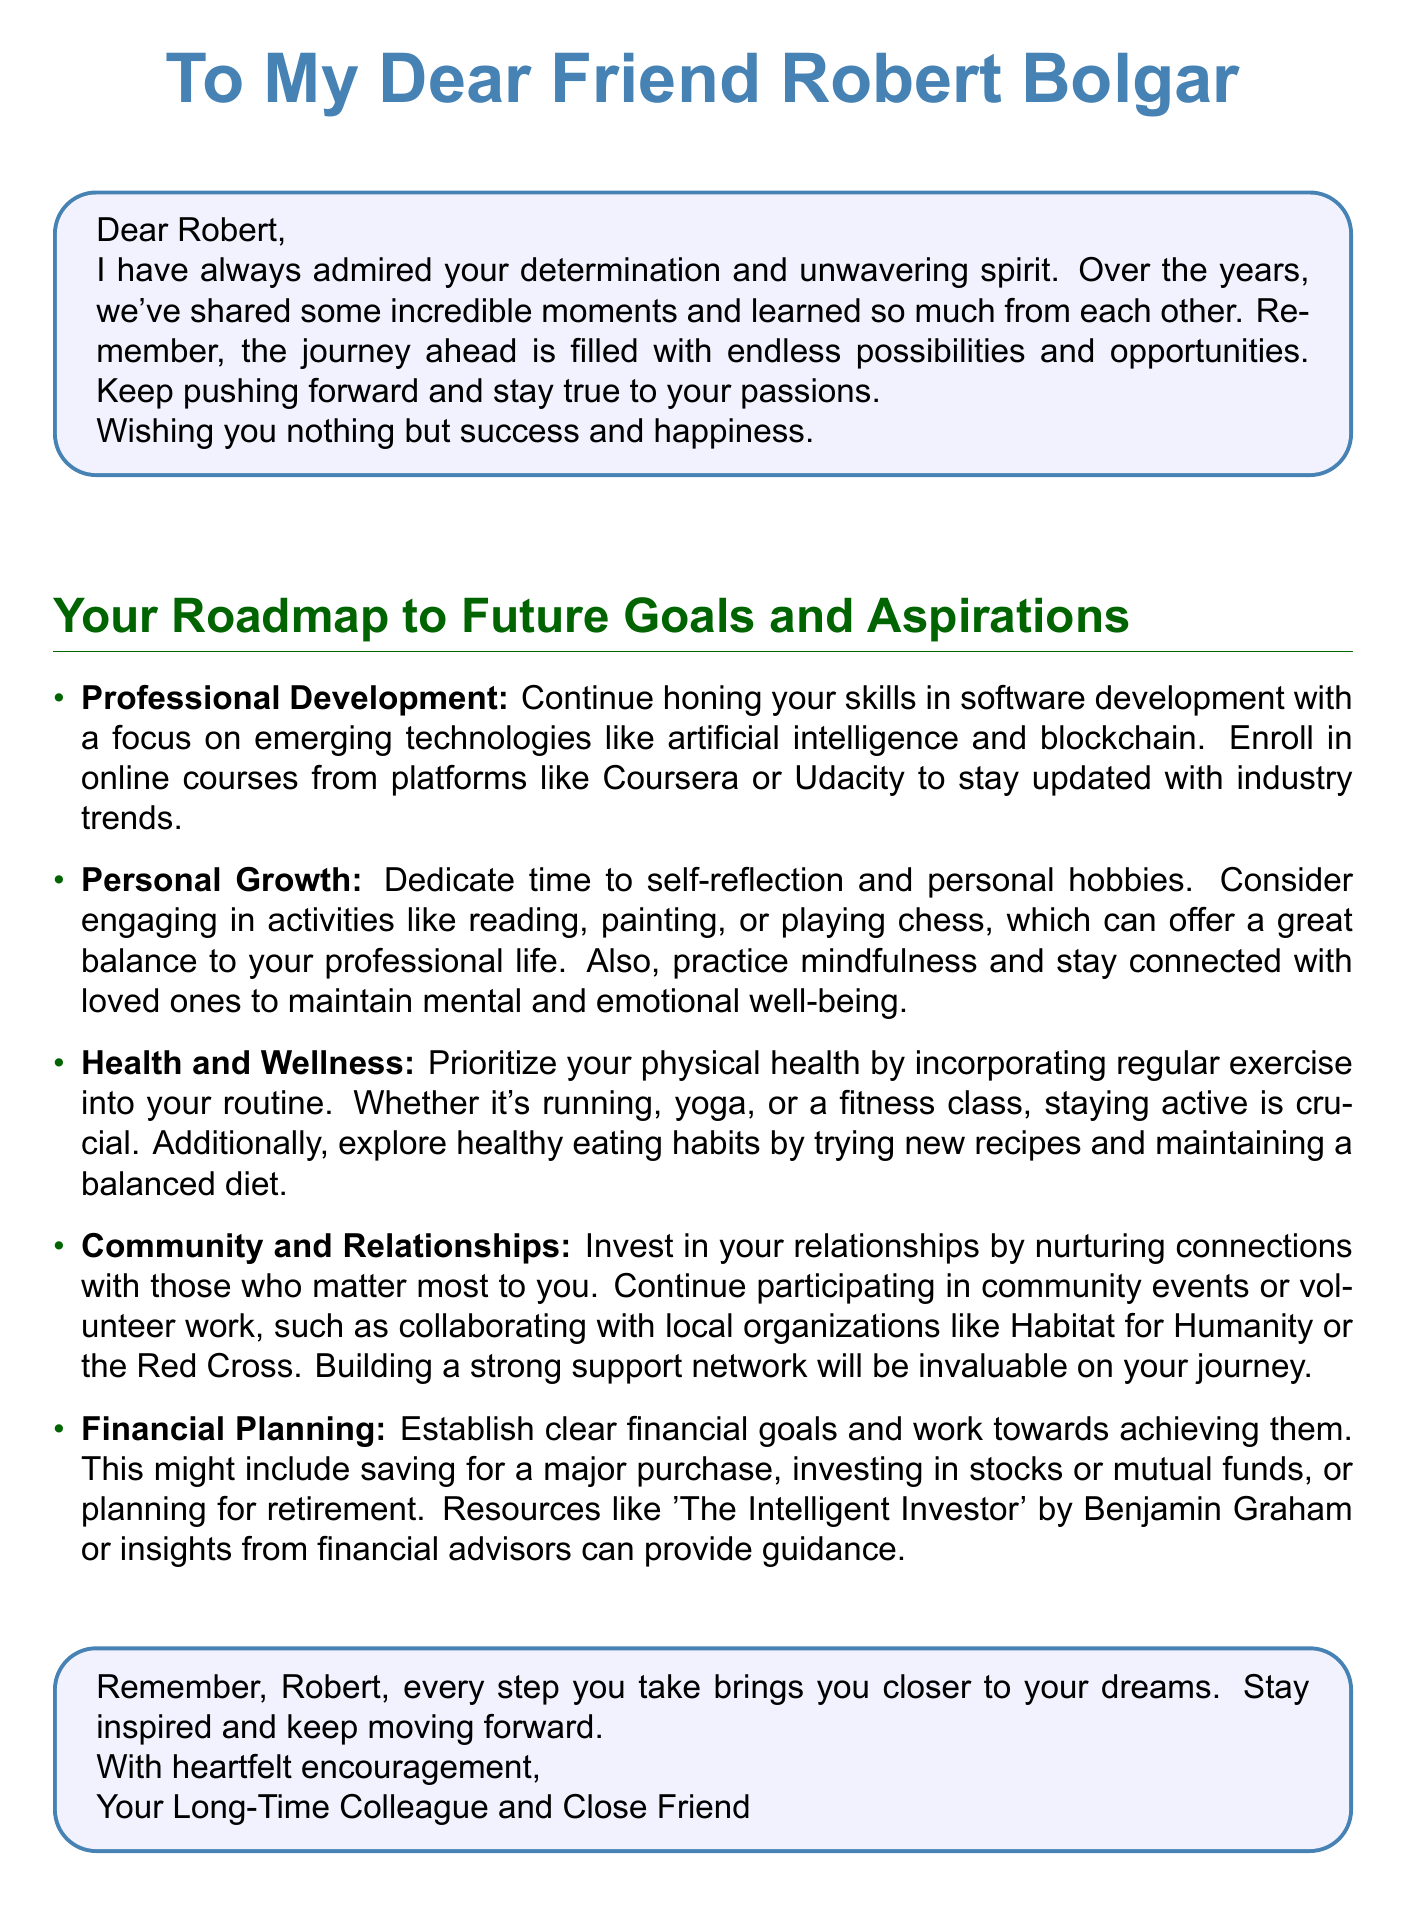What is the recipient's name? The recipient's name is specified in the greeting, which is addressed to Robert Bolgar.
Answer: Robert Bolgar What color is used for the header? The header color is indicated as RGB(70,130,180) in the document.
Answer: RGB(70,130,180) What is the first goal listed in the roadmap? The first goal in the roadmap pertains to professional development and honing skills.
Answer: Professional Development Which book is mentioned in the financial planning section? The document refers to "The Intelligent Investor" by Benjamin Graham as a resource.
Answer: The Intelligent Investor What activities are suggested for personal growth? The suggested activities for personal growth include reading, painting, or playing chess.
Answer: reading, painting, or playing chess What aspect of health is prioritized in the roadmap? The document emphasizes prioritizing physical health through regular exercise.
Answer: Physical health Who is the sender of the greeting card? The sender is referred to as a "Long-Time Colleague and Close Friend" in the closing statement.
Answer: Your Long-Time Colleague and Close Friend What is the overall tone of the greeting card? The card conveys a tone of encouragement and support throughout the message and roadmap.
Answer: Encouragement and support 